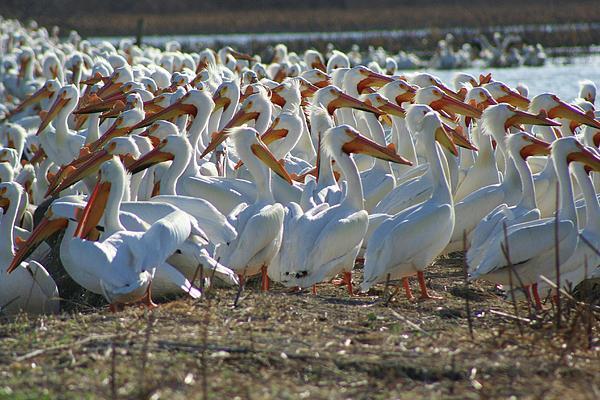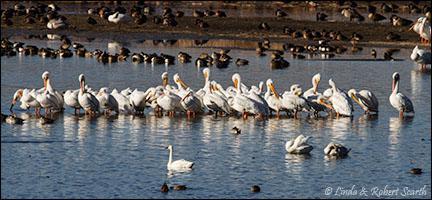The first image is the image on the left, the second image is the image on the right. Considering the images on both sides, is "there are pelicans in the image on the left" valid? Answer yes or no. Yes. The first image is the image on the left, the second image is the image on the right. Considering the images on both sides, is "In one image, pink flamingos are amassed in water." valid? Answer yes or no. No. 